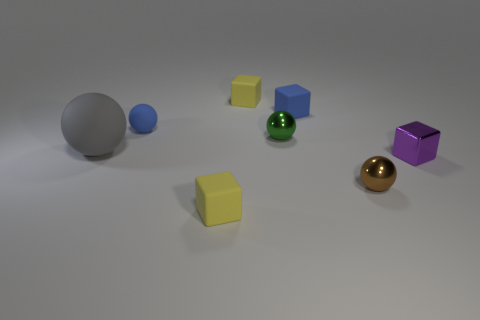What is the texture of the surface on which the objects are placed? The surface appears to have a slightly rough texture with a diffuse reflection, suggesting that it might be made of a matte material, likely not too glossy or shiny. Is there any pattern or design on the surface? There is no discernible pattern or design on the surface; it's a uniform color with natural variations in shading due to the angle of the lighting. 